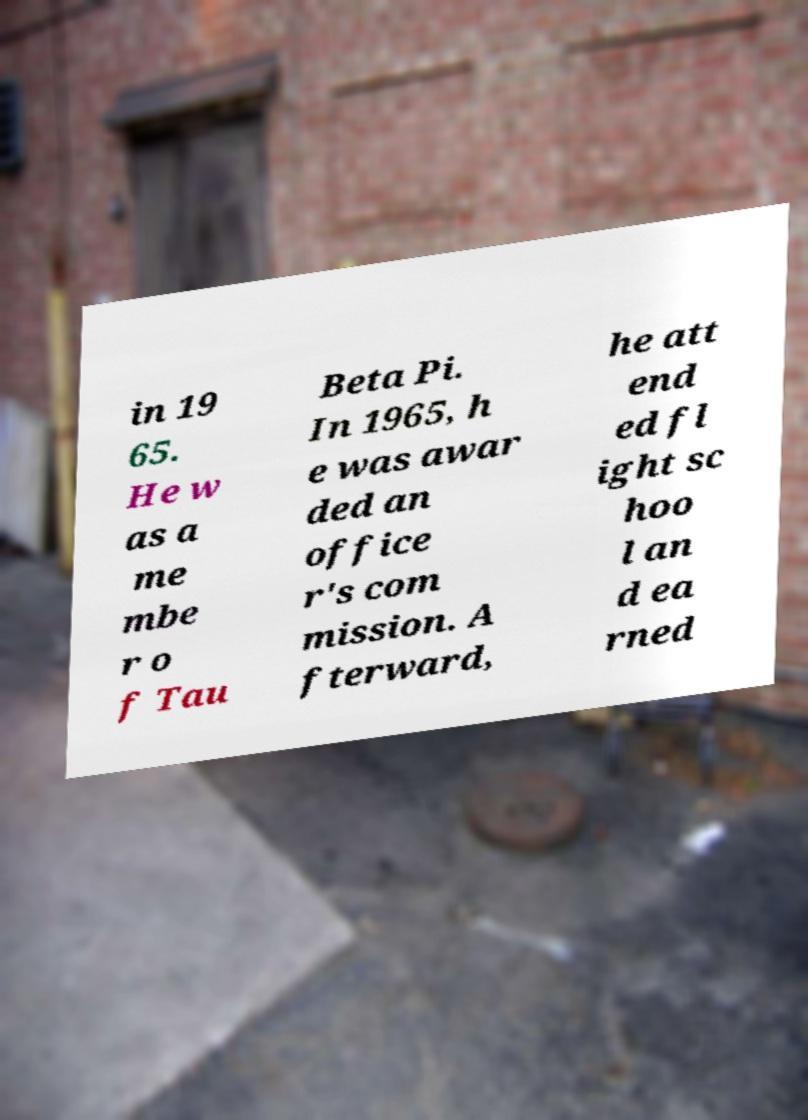I need the written content from this picture converted into text. Can you do that? in 19 65. He w as a me mbe r o f Tau Beta Pi. In 1965, h e was awar ded an office r's com mission. A fterward, he att end ed fl ight sc hoo l an d ea rned 